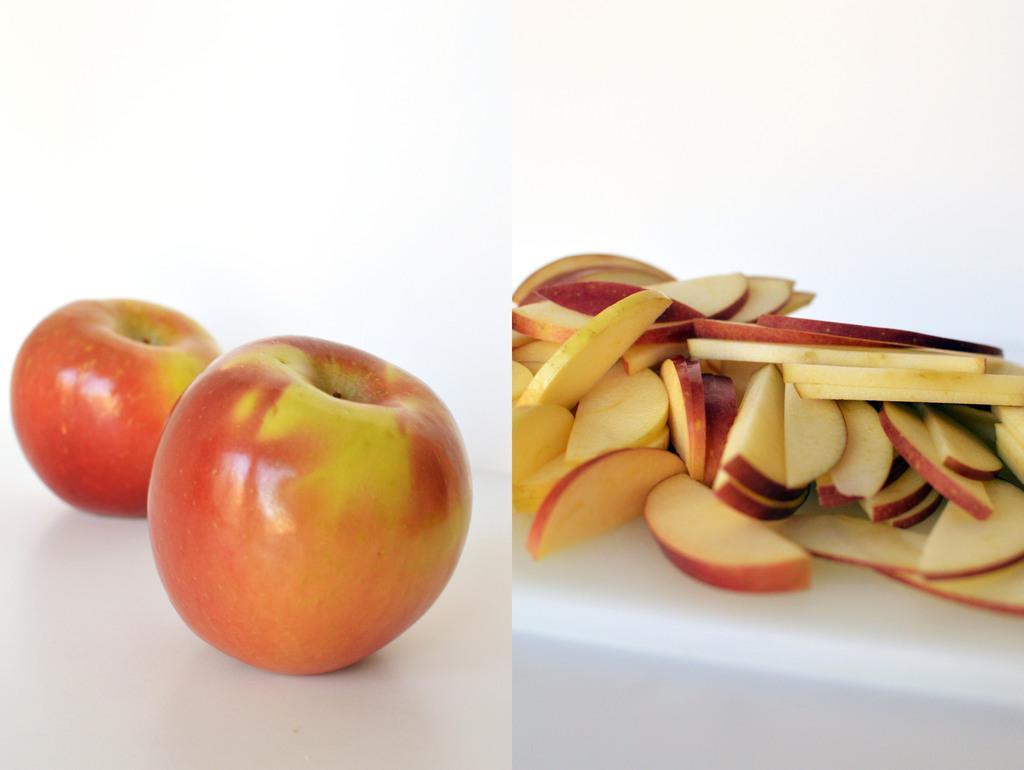Can you describe this image briefly? On the left side of the picture, we see two red apples are placed on the table. In the background, it is white in color. On the right side, we see chopped apples are placed on the white table. In the background, it is white in color. This is an edited image. 